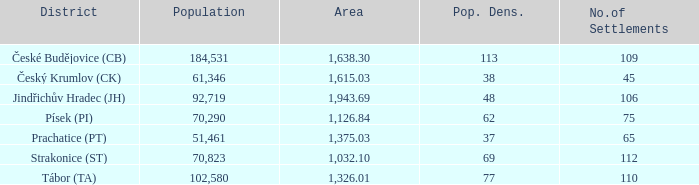What is the lowest population density of Strakonice (st) with more than 112 settlements? None. 